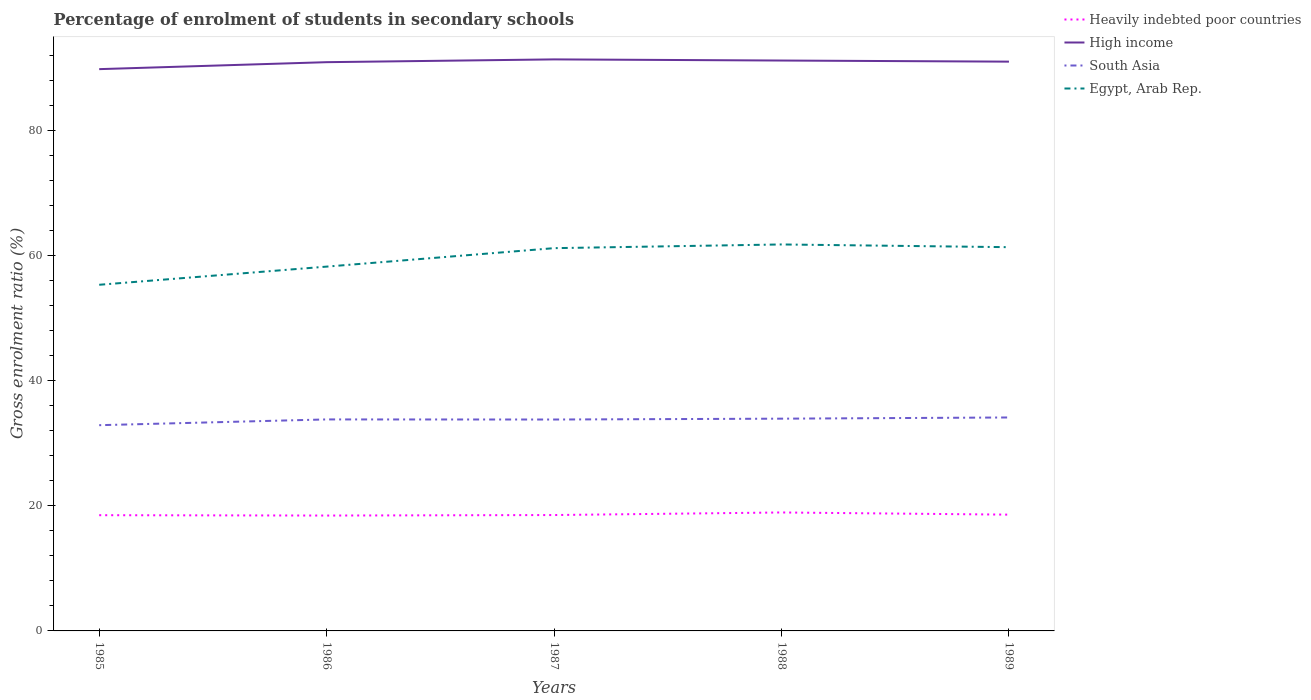Does the line corresponding to Egypt, Arab Rep. intersect with the line corresponding to Heavily indebted poor countries?
Ensure brevity in your answer.  No. Is the number of lines equal to the number of legend labels?
Keep it short and to the point. Yes. Across all years, what is the maximum percentage of students enrolled in secondary schools in South Asia?
Give a very brief answer. 32.87. What is the total percentage of students enrolled in secondary schools in South Asia in the graph?
Make the answer very short. -1.04. What is the difference between the highest and the second highest percentage of students enrolled in secondary schools in High income?
Provide a succinct answer. 1.56. Is the percentage of students enrolled in secondary schools in Heavily indebted poor countries strictly greater than the percentage of students enrolled in secondary schools in High income over the years?
Keep it short and to the point. Yes. How many lines are there?
Offer a very short reply. 4. Does the graph contain any zero values?
Provide a short and direct response. No. Does the graph contain grids?
Make the answer very short. No. What is the title of the graph?
Make the answer very short. Percentage of enrolment of students in secondary schools. Does "Saudi Arabia" appear as one of the legend labels in the graph?
Provide a succinct answer. No. What is the Gross enrolment ratio (%) in Heavily indebted poor countries in 1985?
Provide a succinct answer. 18.49. What is the Gross enrolment ratio (%) of High income in 1985?
Your response must be concise. 89.77. What is the Gross enrolment ratio (%) of South Asia in 1985?
Give a very brief answer. 32.87. What is the Gross enrolment ratio (%) of Egypt, Arab Rep. in 1985?
Provide a succinct answer. 55.31. What is the Gross enrolment ratio (%) of Heavily indebted poor countries in 1986?
Your answer should be compact. 18.44. What is the Gross enrolment ratio (%) of High income in 1986?
Offer a terse response. 90.88. What is the Gross enrolment ratio (%) of South Asia in 1986?
Your answer should be compact. 33.8. What is the Gross enrolment ratio (%) in Egypt, Arab Rep. in 1986?
Ensure brevity in your answer.  58.21. What is the Gross enrolment ratio (%) in Heavily indebted poor countries in 1987?
Provide a short and direct response. 18.52. What is the Gross enrolment ratio (%) of High income in 1987?
Make the answer very short. 91.33. What is the Gross enrolment ratio (%) in South Asia in 1987?
Provide a succinct answer. 33.78. What is the Gross enrolment ratio (%) in Egypt, Arab Rep. in 1987?
Make the answer very short. 61.16. What is the Gross enrolment ratio (%) in Heavily indebted poor countries in 1988?
Make the answer very short. 18.93. What is the Gross enrolment ratio (%) in High income in 1988?
Offer a terse response. 91.14. What is the Gross enrolment ratio (%) of South Asia in 1988?
Your answer should be very brief. 33.92. What is the Gross enrolment ratio (%) in Egypt, Arab Rep. in 1988?
Make the answer very short. 61.75. What is the Gross enrolment ratio (%) of Heavily indebted poor countries in 1989?
Ensure brevity in your answer.  18.58. What is the Gross enrolment ratio (%) in High income in 1989?
Make the answer very short. 90.97. What is the Gross enrolment ratio (%) in South Asia in 1989?
Your answer should be compact. 34.11. What is the Gross enrolment ratio (%) in Egypt, Arab Rep. in 1989?
Provide a succinct answer. 61.32. Across all years, what is the maximum Gross enrolment ratio (%) of Heavily indebted poor countries?
Offer a very short reply. 18.93. Across all years, what is the maximum Gross enrolment ratio (%) in High income?
Offer a very short reply. 91.33. Across all years, what is the maximum Gross enrolment ratio (%) in South Asia?
Offer a very short reply. 34.11. Across all years, what is the maximum Gross enrolment ratio (%) of Egypt, Arab Rep.?
Your answer should be very brief. 61.75. Across all years, what is the minimum Gross enrolment ratio (%) of Heavily indebted poor countries?
Keep it short and to the point. 18.44. Across all years, what is the minimum Gross enrolment ratio (%) of High income?
Your response must be concise. 89.77. Across all years, what is the minimum Gross enrolment ratio (%) of South Asia?
Give a very brief answer. 32.87. Across all years, what is the minimum Gross enrolment ratio (%) in Egypt, Arab Rep.?
Your answer should be compact. 55.31. What is the total Gross enrolment ratio (%) in Heavily indebted poor countries in the graph?
Keep it short and to the point. 92.95. What is the total Gross enrolment ratio (%) of High income in the graph?
Make the answer very short. 454.09. What is the total Gross enrolment ratio (%) of South Asia in the graph?
Ensure brevity in your answer.  168.47. What is the total Gross enrolment ratio (%) of Egypt, Arab Rep. in the graph?
Keep it short and to the point. 297.76. What is the difference between the Gross enrolment ratio (%) in Heavily indebted poor countries in 1985 and that in 1986?
Your answer should be compact. 0.06. What is the difference between the Gross enrolment ratio (%) of High income in 1985 and that in 1986?
Your answer should be very brief. -1.11. What is the difference between the Gross enrolment ratio (%) in South Asia in 1985 and that in 1986?
Your answer should be compact. -0.92. What is the difference between the Gross enrolment ratio (%) in Egypt, Arab Rep. in 1985 and that in 1986?
Ensure brevity in your answer.  -2.9. What is the difference between the Gross enrolment ratio (%) in Heavily indebted poor countries in 1985 and that in 1987?
Provide a short and direct response. -0.02. What is the difference between the Gross enrolment ratio (%) in High income in 1985 and that in 1987?
Offer a very short reply. -1.56. What is the difference between the Gross enrolment ratio (%) of South Asia in 1985 and that in 1987?
Your answer should be very brief. -0.91. What is the difference between the Gross enrolment ratio (%) in Egypt, Arab Rep. in 1985 and that in 1987?
Provide a succinct answer. -5.85. What is the difference between the Gross enrolment ratio (%) of Heavily indebted poor countries in 1985 and that in 1988?
Offer a terse response. -0.43. What is the difference between the Gross enrolment ratio (%) of High income in 1985 and that in 1988?
Provide a short and direct response. -1.37. What is the difference between the Gross enrolment ratio (%) in South Asia in 1985 and that in 1988?
Provide a succinct answer. -1.04. What is the difference between the Gross enrolment ratio (%) in Egypt, Arab Rep. in 1985 and that in 1988?
Offer a very short reply. -6.44. What is the difference between the Gross enrolment ratio (%) of Heavily indebted poor countries in 1985 and that in 1989?
Offer a very short reply. -0.09. What is the difference between the Gross enrolment ratio (%) in High income in 1985 and that in 1989?
Offer a very short reply. -1.2. What is the difference between the Gross enrolment ratio (%) in South Asia in 1985 and that in 1989?
Offer a very short reply. -1.23. What is the difference between the Gross enrolment ratio (%) in Egypt, Arab Rep. in 1985 and that in 1989?
Your answer should be compact. -6.01. What is the difference between the Gross enrolment ratio (%) of Heavily indebted poor countries in 1986 and that in 1987?
Keep it short and to the point. -0.08. What is the difference between the Gross enrolment ratio (%) of High income in 1986 and that in 1987?
Ensure brevity in your answer.  -0.44. What is the difference between the Gross enrolment ratio (%) in South Asia in 1986 and that in 1987?
Your response must be concise. 0.02. What is the difference between the Gross enrolment ratio (%) of Egypt, Arab Rep. in 1986 and that in 1987?
Provide a short and direct response. -2.95. What is the difference between the Gross enrolment ratio (%) in Heavily indebted poor countries in 1986 and that in 1988?
Offer a terse response. -0.49. What is the difference between the Gross enrolment ratio (%) in High income in 1986 and that in 1988?
Offer a very short reply. -0.26. What is the difference between the Gross enrolment ratio (%) of South Asia in 1986 and that in 1988?
Provide a short and direct response. -0.12. What is the difference between the Gross enrolment ratio (%) in Egypt, Arab Rep. in 1986 and that in 1988?
Keep it short and to the point. -3.54. What is the difference between the Gross enrolment ratio (%) of Heavily indebted poor countries in 1986 and that in 1989?
Keep it short and to the point. -0.14. What is the difference between the Gross enrolment ratio (%) in High income in 1986 and that in 1989?
Your answer should be compact. -0.08. What is the difference between the Gross enrolment ratio (%) in South Asia in 1986 and that in 1989?
Keep it short and to the point. -0.31. What is the difference between the Gross enrolment ratio (%) in Egypt, Arab Rep. in 1986 and that in 1989?
Ensure brevity in your answer.  -3.11. What is the difference between the Gross enrolment ratio (%) in Heavily indebted poor countries in 1987 and that in 1988?
Your answer should be very brief. -0.41. What is the difference between the Gross enrolment ratio (%) in High income in 1987 and that in 1988?
Your answer should be compact. 0.18. What is the difference between the Gross enrolment ratio (%) in South Asia in 1987 and that in 1988?
Your answer should be compact. -0.14. What is the difference between the Gross enrolment ratio (%) of Egypt, Arab Rep. in 1987 and that in 1988?
Offer a very short reply. -0.59. What is the difference between the Gross enrolment ratio (%) in Heavily indebted poor countries in 1987 and that in 1989?
Offer a terse response. -0.06. What is the difference between the Gross enrolment ratio (%) in High income in 1987 and that in 1989?
Your answer should be compact. 0.36. What is the difference between the Gross enrolment ratio (%) in South Asia in 1987 and that in 1989?
Give a very brief answer. -0.33. What is the difference between the Gross enrolment ratio (%) of Egypt, Arab Rep. in 1987 and that in 1989?
Make the answer very short. -0.16. What is the difference between the Gross enrolment ratio (%) in Heavily indebted poor countries in 1988 and that in 1989?
Offer a terse response. 0.35. What is the difference between the Gross enrolment ratio (%) in High income in 1988 and that in 1989?
Give a very brief answer. 0.18. What is the difference between the Gross enrolment ratio (%) of South Asia in 1988 and that in 1989?
Offer a very short reply. -0.19. What is the difference between the Gross enrolment ratio (%) in Egypt, Arab Rep. in 1988 and that in 1989?
Provide a short and direct response. 0.44. What is the difference between the Gross enrolment ratio (%) of Heavily indebted poor countries in 1985 and the Gross enrolment ratio (%) of High income in 1986?
Offer a very short reply. -72.39. What is the difference between the Gross enrolment ratio (%) of Heavily indebted poor countries in 1985 and the Gross enrolment ratio (%) of South Asia in 1986?
Offer a very short reply. -15.3. What is the difference between the Gross enrolment ratio (%) of Heavily indebted poor countries in 1985 and the Gross enrolment ratio (%) of Egypt, Arab Rep. in 1986?
Ensure brevity in your answer.  -39.72. What is the difference between the Gross enrolment ratio (%) of High income in 1985 and the Gross enrolment ratio (%) of South Asia in 1986?
Your answer should be compact. 55.97. What is the difference between the Gross enrolment ratio (%) in High income in 1985 and the Gross enrolment ratio (%) in Egypt, Arab Rep. in 1986?
Give a very brief answer. 31.56. What is the difference between the Gross enrolment ratio (%) of South Asia in 1985 and the Gross enrolment ratio (%) of Egypt, Arab Rep. in 1986?
Provide a succinct answer. -25.34. What is the difference between the Gross enrolment ratio (%) in Heavily indebted poor countries in 1985 and the Gross enrolment ratio (%) in High income in 1987?
Your answer should be very brief. -72.83. What is the difference between the Gross enrolment ratio (%) in Heavily indebted poor countries in 1985 and the Gross enrolment ratio (%) in South Asia in 1987?
Make the answer very short. -15.29. What is the difference between the Gross enrolment ratio (%) of Heavily indebted poor countries in 1985 and the Gross enrolment ratio (%) of Egypt, Arab Rep. in 1987?
Keep it short and to the point. -42.67. What is the difference between the Gross enrolment ratio (%) in High income in 1985 and the Gross enrolment ratio (%) in South Asia in 1987?
Your answer should be very brief. 55.99. What is the difference between the Gross enrolment ratio (%) in High income in 1985 and the Gross enrolment ratio (%) in Egypt, Arab Rep. in 1987?
Make the answer very short. 28.61. What is the difference between the Gross enrolment ratio (%) of South Asia in 1985 and the Gross enrolment ratio (%) of Egypt, Arab Rep. in 1987?
Provide a succinct answer. -28.29. What is the difference between the Gross enrolment ratio (%) of Heavily indebted poor countries in 1985 and the Gross enrolment ratio (%) of High income in 1988?
Ensure brevity in your answer.  -72.65. What is the difference between the Gross enrolment ratio (%) in Heavily indebted poor countries in 1985 and the Gross enrolment ratio (%) in South Asia in 1988?
Your response must be concise. -15.42. What is the difference between the Gross enrolment ratio (%) of Heavily indebted poor countries in 1985 and the Gross enrolment ratio (%) of Egypt, Arab Rep. in 1988?
Give a very brief answer. -43.26. What is the difference between the Gross enrolment ratio (%) of High income in 1985 and the Gross enrolment ratio (%) of South Asia in 1988?
Offer a very short reply. 55.85. What is the difference between the Gross enrolment ratio (%) of High income in 1985 and the Gross enrolment ratio (%) of Egypt, Arab Rep. in 1988?
Give a very brief answer. 28.01. What is the difference between the Gross enrolment ratio (%) of South Asia in 1985 and the Gross enrolment ratio (%) of Egypt, Arab Rep. in 1988?
Your answer should be compact. -28.88. What is the difference between the Gross enrolment ratio (%) in Heavily indebted poor countries in 1985 and the Gross enrolment ratio (%) in High income in 1989?
Ensure brevity in your answer.  -72.47. What is the difference between the Gross enrolment ratio (%) in Heavily indebted poor countries in 1985 and the Gross enrolment ratio (%) in South Asia in 1989?
Provide a short and direct response. -15.62. What is the difference between the Gross enrolment ratio (%) of Heavily indebted poor countries in 1985 and the Gross enrolment ratio (%) of Egypt, Arab Rep. in 1989?
Offer a terse response. -42.83. What is the difference between the Gross enrolment ratio (%) of High income in 1985 and the Gross enrolment ratio (%) of South Asia in 1989?
Your answer should be very brief. 55.66. What is the difference between the Gross enrolment ratio (%) in High income in 1985 and the Gross enrolment ratio (%) in Egypt, Arab Rep. in 1989?
Provide a short and direct response. 28.45. What is the difference between the Gross enrolment ratio (%) in South Asia in 1985 and the Gross enrolment ratio (%) in Egypt, Arab Rep. in 1989?
Provide a succinct answer. -28.44. What is the difference between the Gross enrolment ratio (%) in Heavily indebted poor countries in 1986 and the Gross enrolment ratio (%) in High income in 1987?
Provide a short and direct response. -72.89. What is the difference between the Gross enrolment ratio (%) in Heavily indebted poor countries in 1986 and the Gross enrolment ratio (%) in South Asia in 1987?
Your answer should be very brief. -15.34. What is the difference between the Gross enrolment ratio (%) of Heavily indebted poor countries in 1986 and the Gross enrolment ratio (%) of Egypt, Arab Rep. in 1987?
Provide a short and direct response. -42.73. What is the difference between the Gross enrolment ratio (%) in High income in 1986 and the Gross enrolment ratio (%) in South Asia in 1987?
Provide a short and direct response. 57.1. What is the difference between the Gross enrolment ratio (%) of High income in 1986 and the Gross enrolment ratio (%) of Egypt, Arab Rep. in 1987?
Offer a terse response. 29.72. What is the difference between the Gross enrolment ratio (%) in South Asia in 1986 and the Gross enrolment ratio (%) in Egypt, Arab Rep. in 1987?
Ensure brevity in your answer.  -27.37. What is the difference between the Gross enrolment ratio (%) of Heavily indebted poor countries in 1986 and the Gross enrolment ratio (%) of High income in 1988?
Offer a terse response. -72.71. What is the difference between the Gross enrolment ratio (%) of Heavily indebted poor countries in 1986 and the Gross enrolment ratio (%) of South Asia in 1988?
Your answer should be very brief. -15.48. What is the difference between the Gross enrolment ratio (%) of Heavily indebted poor countries in 1986 and the Gross enrolment ratio (%) of Egypt, Arab Rep. in 1988?
Provide a succinct answer. -43.32. What is the difference between the Gross enrolment ratio (%) of High income in 1986 and the Gross enrolment ratio (%) of South Asia in 1988?
Provide a short and direct response. 56.97. What is the difference between the Gross enrolment ratio (%) in High income in 1986 and the Gross enrolment ratio (%) in Egypt, Arab Rep. in 1988?
Your answer should be very brief. 29.13. What is the difference between the Gross enrolment ratio (%) of South Asia in 1986 and the Gross enrolment ratio (%) of Egypt, Arab Rep. in 1988?
Provide a succinct answer. -27.96. What is the difference between the Gross enrolment ratio (%) in Heavily indebted poor countries in 1986 and the Gross enrolment ratio (%) in High income in 1989?
Give a very brief answer. -72.53. What is the difference between the Gross enrolment ratio (%) of Heavily indebted poor countries in 1986 and the Gross enrolment ratio (%) of South Asia in 1989?
Offer a very short reply. -15.67. What is the difference between the Gross enrolment ratio (%) of Heavily indebted poor countries in 1986 and the Gross enrolment ratio (%) of Egypt, Arab Rep. in 1989?
Give a very brief answer. -42.88. What is the difference between the Gross enrolment ratio (%) in High income in 1986 and the Gross enrolment ratio (%) in South Asia in 1989?
Make the answer very short. 56.77. What is the difference between the Gross enrolment ratio (%) in High income in 1986 and the Gross enrolment ratio (%) in Egypt, Arab Rep. in 1989?
Provide a short and direct response. 29.56. What is the difference between the Gross enrolment ratio (%) in South Asia in 1986 and the Gross enrolment ratio (%) in Egypt, Arab Rep. in 1989?
Make the answer very short. -27.52. What is the difference between the Gross enrolment ratio (%) in Heavily indebted poor countries in 1987 and the Gross enrolment ratio (%) in High income in 1988?
Provide a short and direct response. -72.63. What is the difference between the Gross enrolment ratio (%) of Heavily indebted poor countries in 1987 and the Gross enrolment ratio (%) of South Asia in 1988?
Your response must be concise. -15.4. What is the difference between the Gross enrolment ratio (%) of Heavily indebted poor countries in 1987 and the Gross enrolment ratio (%) of Egypt, Arab Rep. in 1988?
Provide a short and direct response. -43.24. What is the difference between the Gross enrolment ratio (%) in High income in 1987 and the Gross enrolment ratio (%) in South Asia in 1988?
Offer a very short reply. 57.41. What is the difference between the Gross enrolment ratio (%) in High income in 1987 and the Gross enrolment ratio (%) in Egypt, Arab Rep. in 1988?
Offer a very short reply. 29.57. What is the difference between the Gross enrolment ratio (%) in South Asia in 1987 and the Gross enrolment ratio (%) in Egypt, Arab Rep. in 1988?
Your response must be concise. -27.97. What is the difference between the Gross enrolment ratio (%) of Heavily indebted poor countries in 1987 and the Gross enrolment ratio (%) of High income in 1989?
Offer a very short reply. -72.45. What is the difference between the Gross enrolment ratio (%) of Heavily indebted poor countries in 1987 and the Gross enrolment ratio (%) of South Asia in 1989?
Provide a succinct answer. -15.59. What is the difference between the Gross enrolment ratio (%) in Heavily indebted poor countries in 1987 and the Gross enrolment ratio (%) in Egypt, Arab Rep. in 1989?
Your answer should be compact. -42.8. What is the difference between the Gross enrolment ratio (%) of High income in 1987 and the Gross enrolment ratio (%) of South Asia in 1989?
Provide a succinct answer. 57.22. What is the difference between the Gross enrolment ratio (%) of High income in 1987 and the Gross enrolment ratio (%) of Egypt, Arab Rep. in 1989?
Your answer should be compact. 30.01. What is the difference between the Gross enrolment ratio (%) of South Asia in 1987 and the Gross enrolment ratio (%) of Egypt, Arab Rep. in 1989?
Give a very brief answer. -27.54. What is the difference between the Gross enrolment ratio (%) of Heavily indebted poor countries in 1988 and the Gross enrolment ratio (%) of High income in 1989?
Your answer should be compact. -72.04. What is the difference between the Gross enrolment ratio (%) in Heavily indebted poor countries in 1988 and the Gross enrolment ratio (%) in South Asia in 1989?
Your answer should be very brief. -15.18. What is the difference between the Gross enrolment ratio (%) of Heavily indebted poor countries in 1988 and the Gross enrolment ratio (%) of Egypt, Arab Rep. in 1989?
Provide a succinct answer. -42.39. What is the difference between the Gross enrolment ratio (%) in High income in 1988 and the Gross enrolment ratio (%) in South Asia in 1989?
Your answer should be very brief. 57.03. What is the difference between the Gross enrolment ratio (%) of High income in 1988 and the Gross enrolment ratio (%) of Egypt, Arab Rep. in 1989?
Offer a terse response. 29.82. What is the difference between the Gross enrolment ratio (%) in South Asia in 1988 and the Gross enrolment ratio (%) in Egypt, Arab Rep. in 1989?
Your answer should be compact. -27.4. What is the average Gross enrolment ratio (%) of Heavily indebted poor countries per year?
Your response must be concise. 18.59. What is the average Gross enrolment ratio (%) in High income per year?
Make the answer very short. 90.82. What is the average Gross enrolment ratio (%) in South Asia per year?
Offer a terse response. 33.69. What is the average Gross enrolment ratio (%) in Egypt, Arab Rep. per year?
Provide a succinct answer. 59.55. In the year 1985, what is the difference between the Gross enrolment ratio (%) in Heavily indebted poor countries and Gross enrolment ratio (%) in High income?
Make the answer very short. -71.28. In the year 1985, what is the difference between the Gross enrolment ratio (%) of Heavily indebted poor countries and Gross enrolment ratio (%) of South Asia?
Offer a very short reply. -14.38. In the year 1985, what is the difference between the Gross enrolment ratio (%) of Heavily indebted poor countries and Gross enrolment ratio (%) of Egypt, Arab Rep.?
Keep it short and to the point. -36.82. In the year 1985, what is the difference between the Gross enrolment ratio (%) in High income and Gross enrolment ratio (%) in South Asia?
Provide a short and direct response. 56.89. In the year 1985, what is the difference between the Gross enrolment ratio (%) in High income and Gross enrolment ratio (%) in Egypt, Arab Rep.?
Your answer should be compact. 34.46. In the year 1985, what is the difference between the Gross enrolment ratio (%) in South Asia and Gross enrolment ratio (%) in Egypt, Arab Rep.?
Keep it short and to the point. -22.44. In the year 1986, what is the difference between the Gross enrolment ratio (%) of Heavily indebted poor countries and Gross enrolment ratio (%) of High income?
Make the answer very short. -72.45. In the year 1986, what is the difference between the Gross enrolment ratio (%) in Heavily indebted poor countries and Gross enrolment ratio (%) in South Asia?
Make the answer very short. -15.36. In the year 1986, what is the difference between the Gross enrolment ratio (%) of Heavily indebted poor countries and Gross enrolment ratio (%) of Egypt, Arab Rep.?
Give a very brief answer. -39.78. In the year 1986, what is the difference between the Gross enrolment ratio (%) of High income and Gross enrolment ratio (%) of South Asia?
Give a very brief answer. 57.09. In the year 1986, what is the difference between the Gross enrolment ratio (%) in High income and Gross enrolment ratio (%) in Egypt, Arab Rep.?
Your response must be concise. 32.67. In the year 1986, what is the difference between the Gross enrolment ratio (%) of South Asia and Gross enrolment ratio (%) of Egypt, Arab Rep.?
Offer a very short reply. -24.42. In the year 1987, what is the difference between the Gross enrolment ratio (%) of Heavily indebted poor countries and Gross enrolment ratio (%) of High income?
Offer a terse response. -72.81. In the year 1987, what is the difference between the Gross enrolment ratio (%) of Heavily indebted poor countries and Gross enrolment ratio (%) of South Asia?
Provide a short and direct response. -15.26. In the year 1987, what is the difference between the Gross enrolment ratio (%) of Heavily indebted poor countries and Gross enrolment ratio (%) of Egypt, Arab Rep.?
Your answer should be very brief. -42.65. In the year 1987, what is the difference between the Gross enrolment ratio (%) in High income and Gross enrolment ratio (%) in South Asia?
Your answer should be very brief. 57.55. In the year 1987, what is the difference between the Gross enrolment ratio (%) of High income and Gross enrolment ratio (%) of Egypt, Arab Rep.?
Provide a short and direct response. 30.16. In the year 1987, what is the difference between the Gross enrolment ratio (%) of South Asia and Gross enrolment ratio (%) of Egypt, Arab Rep.?
Keep it short and to the point. -27.38. In the year 1988, what is the difference between the Gross enrolment ratio (%) in Heavily indebted poor countries and Gross enrolment ratio (%) in High income?
Your answer should be very brief. -72.22. In the year 1988, what is the difference between the Gross enrolment ratio (%) in Heavily indebted poor countries and Gross enrolment ratio (%) in South Asia?
Provide a succinct answer. -14.99. In the year 1988, what is the difference between the Gross enrolment ratio (%) of Heavily indebted poor countries and Gross enrolment ratio (%) of Egypt, Arab Rep.?
Provide a succinct answer. -42.83. In the year 1988, what is the difference between the Gross enrolment ratio (%) of High income and Gross enrolment ratio (%) of South Asia?
Offer a very short reply. 57.23. In the year 1988, what is the difference between the Gross enrolment ratio (%) in High income and Gross enrolment ratio (%) in Egypt, Arab Rep.?
Ensure brevity in your answer.  29.39. In the year 1988, what is the difference between the Gross enrolment ratio (%) in South Asia and Gross enrolment ratio (%) in Egypt, Arab Rep.?
Keep it short and to the point. -27.84. In the year 1989, what is the difference between the Gross enrolment ratio (%) of Heavily indebted poor countries and Gross enrolment ratio (%) of High income?
Your answer should be compact. -72.39. In the year 1989, what is the difference between the Gross enrolment ratio (%) of Heavily indebted poor countries and Gross enrolment ratio (%) of South Asia?
Provide a succinct answer. -15.53. In the year 1989, what is the difference between the Gross enrolment ratio (%) of Heavily indebted poor countries and Gross enrolment ratio (%) of Egypt, Arab Rep.?
Your answer should be compact. -42.74. In the year 1989, what is the difference between the Gross enrolment ratio (%) in High income and Gross enrolment ratio (%) in South Asia?
Offer a terse response. 56.86. In the year 1989, what is the difference between the Gross enrolment ratio (%) of High income and Gross enrolment ratio (%) of Egypt, Arab Rep.?
Offer a very short reply. 29.65. In the year 1989, what is the difference between the Gross enrolment ratio (%) in South Asia and Gross enrolment ratio (%) in Egypt, Arab Rep.?
Offer a terse response. -27.21. What is the ratio of the Gross enrolment ratio (%) of Heavily indebted poor countries in 1985 to that in 1986?
Provide a short and direct response. 1. What is the ratio of the Gross enrolment ratio (%) of South Asia in 1985 to that in 1986?
Provide a succinct answer. 0.97. What is the ratio of the Gross enrolment ratio (%) of Egypt, Arab Rep. in 1985 to that in 1986?
Provide a short and direct response. 0.95. What is the ratio of the Gross enrolment ratio (%) in High income in 1985 to that in 1987?
Your response must be concise. 0.98. What is the ratio of the Gross enrolment ratio (%) in South Asia in 1985 to that in 1987?
Make the answer very short. 0.97. What is the ratio of the Gross enrolment ratio (%) of Egypt, Arab Rep. in 1985 to that in 1987?
Provide a succinct answer. 0.9. What is the ratio of the Gross enrolment ratio (%) in Heavily indebted poor countries in 1985 to that in 1988?
Your response must be concise. 0.98. What is the ratio of the Gross enrolment ratio (%) in High income in 1985 to that in 1988?
Ensure brevity in your answer.  0.98. What is the ratio of the Gross enrolment ratio (%) of South Asia in 1985 to that in 1988?
Make the answer very short. 0.97. What is the ratio of the Gross enrolment ratio (%) in Egypt, Arab Rep. in 1985 to that in 1988?
Offer a very short reply. 0.9. What is the ratio of the Gross enrolment ratio (%) of South Asia in 1985 to that in 1989?
Make the answer very short. 0.96. What is the ratio of the Gross enrolment ratio (%) of Egypt, Arab Rep. in 1985 to that in 1989?
Offer a very short reply. 0.9. What is the ratio of the Gross enrolment ratio (%) of South Asia in 1986 to that in 1987?
Offer a very short reply. 1. What is the ratio of the Gross enrolment ratio (%) in Egypt, Arab Rep. in 1986 to that in 1987?
Offer a terse response. 0.95. What is the ratio of the Gross enrolment ratio (%) in Heavily indebted poor countries in 1986 to that in 1988?
Your answer should be very brief. 0.97. What is the ratio of the Gross enrolment ratio (%) in High income in 1986 to that in 1988?
Give a very brief answer. 1. What is the ratio of the Gross enrolment ratio (%) of South Asia in 1986 to that in 1988?
Offer a very short reply. 1. What is the ratio of the Gross enrolment ratio (%) of Egypt, Arab Rep. in 1986 to that in 1988?
Provide a short and direct response. 0.94. What is the ratio of the Gross enrolment ratio (%) in High income in 1986 to that in 1989?
Offer a very short reply. 1. What is the ratio of the Gross enrolment ratio (%) of South Asia in 1986 to that in 1989?
Make the answer very short. 0.99. What is the ratio of the Gross enrolment ratio (%) of Egypt, Arab Rep. in 1986 to that in 1989?
Your answer should be very brief. 0.95. What is the ratio of the Gross enrolment ratio (%) of Heavily indebted poor countries in 1987 to that in 1988?
Ensure brevity in your answer.  0.98. What is the ratio of the Gross enrolment ratio (%) of High income in 1987 to that in 1988?
Keep it short and to the point. 1. What is the ratio of the Gross enrolment ratio (%) in High income in 1987 to that in 1989?
Offer a very short reply. 1. What is the ratio of the Gross enrolment ratio (%) of South Asia in 1987 to that in 1989?
Provide a succinct answer. 0.99. What is the ratio of the Gross enrolment ratio (%) in Heavily indebted poor countries in 1988 to that in 1989?
Provide a short and direct response. 1.02. What is the ratio of the Gross enrolment ratio (%) in Egypt, Arab Rep. in 1988 to that in 1989?
Give a very brief answer. 1.01. What is the difference between the highest and the second highest Gross enrolment ratio (%) of Heavily indebted poor countries?
Your answer should be compact. 0.35. What is the difference between the highest and the second highest Gross enrolment ratio (%) in High income?
Provide a succinct answer. 0.18. What is the difference between the highest and the second highest Gross enrolment ratio (%) in South Asia?
Give a very brief answer. 0.19. What is the difference between the highest and the second highest Gross enrolment ratio (%) in Egypt, Arab Rep.?
Your answer should be very brief. 0.44. What is the difference between the highest and the lowest Gross enrolment ratio (%) of Heavily indebted poor countries?
Keep it short and to the point. 0.49. What is the difference between the highest and the lowest Gross enrolment ratio (%) in High income?
Your response must be concise. 1.56. What is the difference between the highest and the lowest Gross enrolment ratio (%) in South Asia?
Provide a succinct answer. 1.23. What is the difference between the highest and the lowest Gross enrolment ratio (%) in Egypt, Arab Rep.?
Make the answer very short. 6.44. 